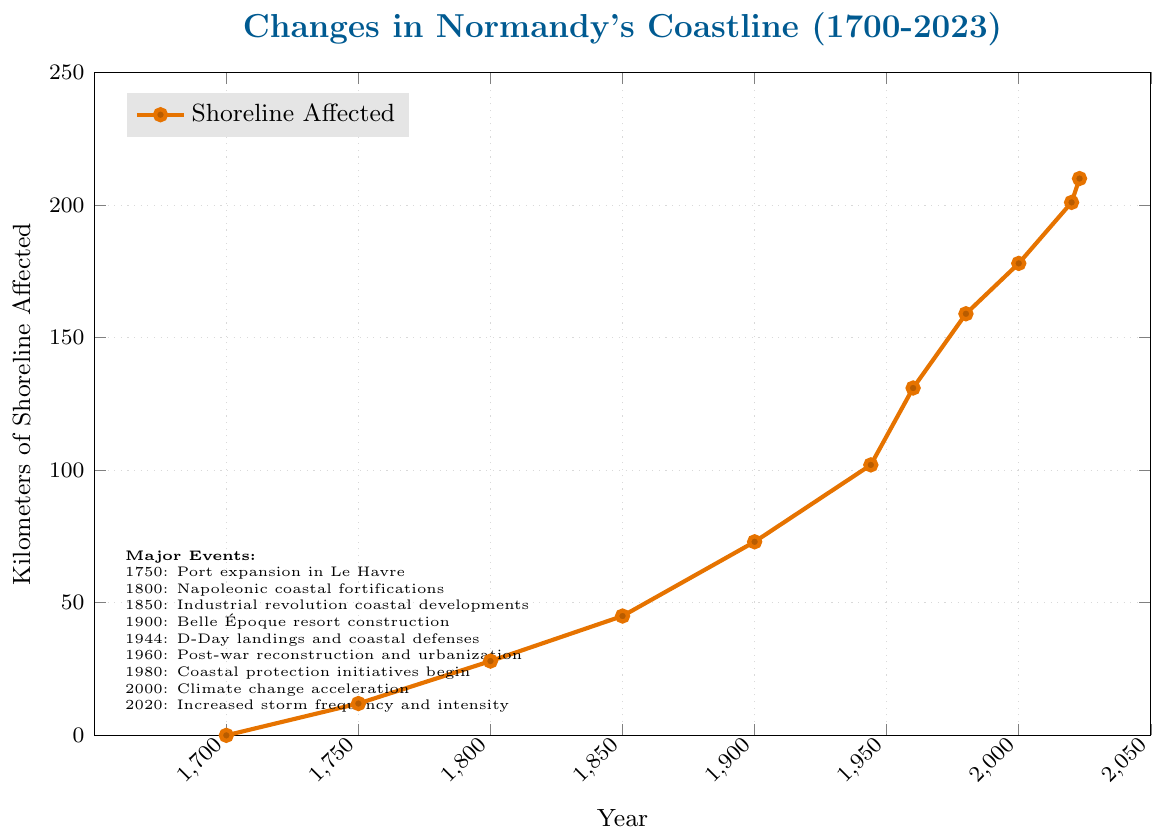What is the total increase in kilometers of shoreline affected between 1700 and 2023? To find the total increase, subtract the kilometers affected in 1700 from those in 2023. The calculation is 210 km (2023) - 0 km (1700).
Answer: 210 km How much did the shoreline affected increase between 1944 and 1960? Subtract the kilometers affected in 1944 from those in 1960: 131 km (1960) - 102 km (1944).
Answer: 29 km Between which two consecutive periods did the shoreline affected increase the most? Compare the differences between all consecutive periods: 
1750-1800: 28 km - 12 km = 16 km,
1800-1850: 45 km - 28 km = 17 km,
1850-1900: 73 km - 45 km = 28 km,
1900-1944: 102 km - 73 km = 29 km,
1944-1960: 131 km - 102 km = 29 km,
1960-1980: 159 km - 131 km = 28 km,
1980-2000: 178 km - 159 km = 19 km,
2000-2020: 201 km - 178 km = 23 km,
2020-2023: 210 km - 201 km = 9 km.
The largest increase is between 1900-1944 and 1944-1960, both with 29 km.
Answer: 1900-1944 and 1944-1960 During what major event did the largest single increase in shoreline affected occur? Refer to the major events listed and identify the largest increase between consecutive events.
The largest increase (29 km) occurred during and after the D-Day landings and coastal defenses (1944-1960).
Answer: D-Day landings and coastal defenses What is the average increase in kilometers of shoreline affected per 50-year period from 1700 to 2020? Calculate the total increase over 320 years (2020-1700), which is 201 km, and then divide by the number of 50-year periods (320/50=6.4 periods). The formula is 201 km / 6.4 periods = 31.4 km per period.
Answer: 31.4 km per period How does the rate of change from 1980 to 2000 compare to the rate from 2000 to 2020? Find the increases: 1980-2000: 178 km - 159 km = 19 km, 2000-2020: 201 km - 178 km = 23 km. Compare rates: 19 km over 20 years vs 23 km over 20 years. The rate of change has increased.
Answer: Increased What visual markers distinguish significant events in the timeline on the figure? The significant events are denoted with textual annotations beside them on the graph, indicating their approximate timelines. Additionally, these events cause noticeable inflection points in the line's slope.
Answer: Textual annotations and inflection points In which period did the shoreline affected first exceed 100 kilometers? Identify when the data first shows more than 100 km affected: This happened in 1944, with 102 km.
Answer: 1944 How many years did it take for the kilometers of affected shoreline to increase from 0 to 100? Find the earliest year for 100 km (1944) and subtract the starting year (1700): 1944 - 1700 = 244 years.
Answer: 244 years What was the rate of increase in kilometers per year between 1960 and 1980? Calculate the increase: 159 km (1980) - 131 km (1960) = 28 km. Calculate the period length: 1980 - 1960 = 20 years. Divide the increase by the period length: 28 km / 20 years = 1.4 km per year.
Answer: 1.4 km per year 